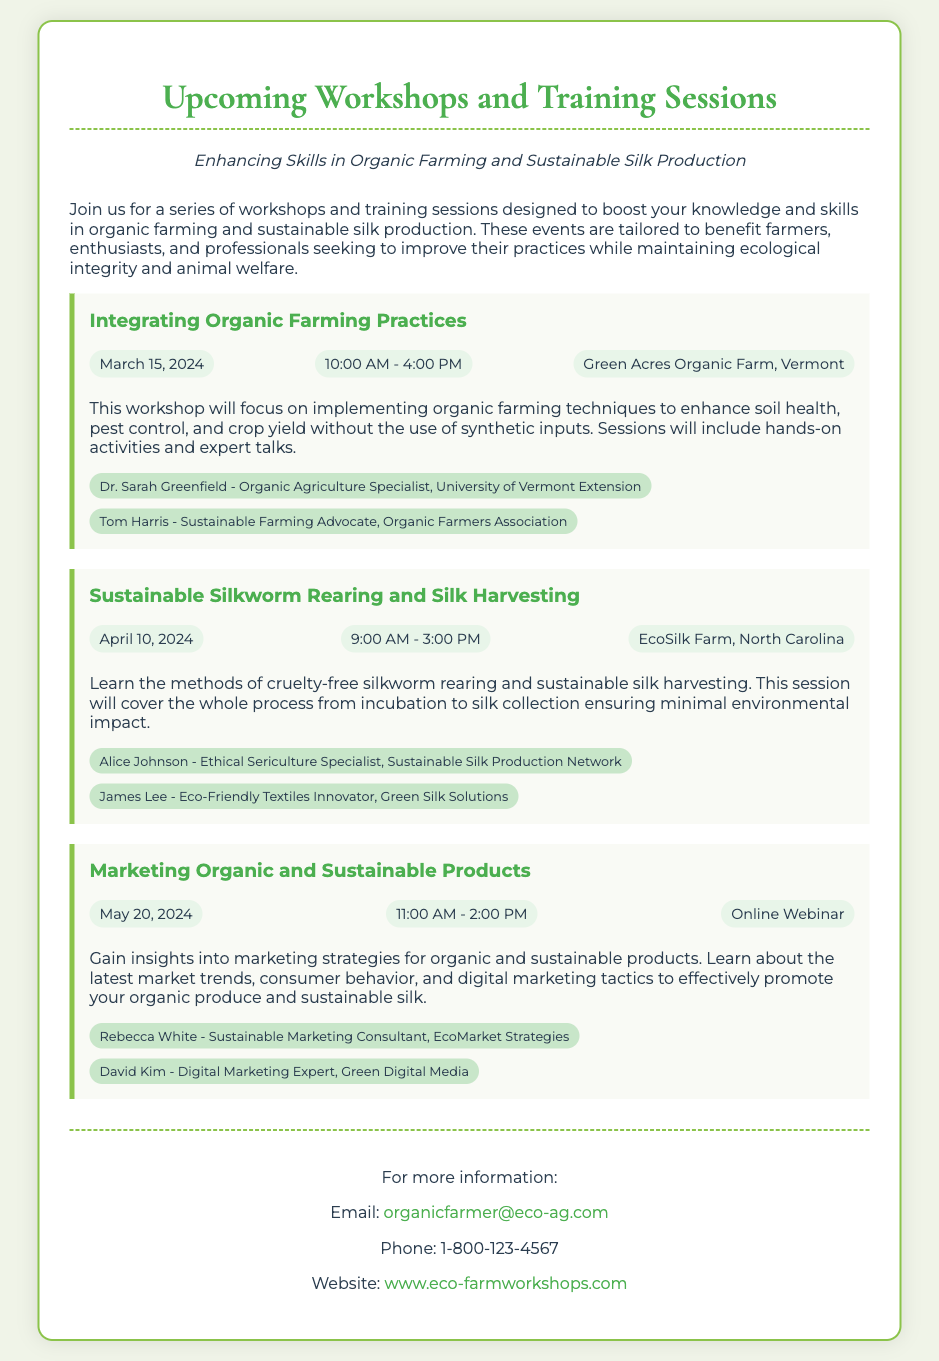What is the title of the first workshop? The title of the first workshop is found within the event section of the document.
Answer: Integrating Organic Farming Practices When is the sustainable silkworm rearing workshop scheduled? The date for the sustainable silkworm rearing workshop is listed in the event details.
Answer: April 10, 2024 Who is the speaker for the marketing webinar? The document provides speaker names for each event, including the marketing webinar.
Answer: Rebecca White What time does the "Integrating Organic Farming Practices" workshop begin? The start time for the "Integrating Organic Farming Practices" workshop is mentioned in the event details.
Answer: 10:00 AM How many workshops are listed in the document? The total number of workshops can be counted from the event sections provided.
Answer: Three What is the location of the sustainable silk workshop? The location for the sustainable silk workshop is specified in the event details.
Answer: EcoSilk Farm, North Carolina What is the main focus of the workshop on April 10, 2024? The description for the April 10 workshop outlines its main focus.
Answer: Cruelty-free silkworm rearing and sustainable silk harvesting Is there an online event scheduled? The document mentions various events, including any that are online.
Answer: Yes What is the contact email mentioned for more information? The email for contact is provided in the contact information section at the end of the document.
Answer: organicfarmer@eco-ag.com 